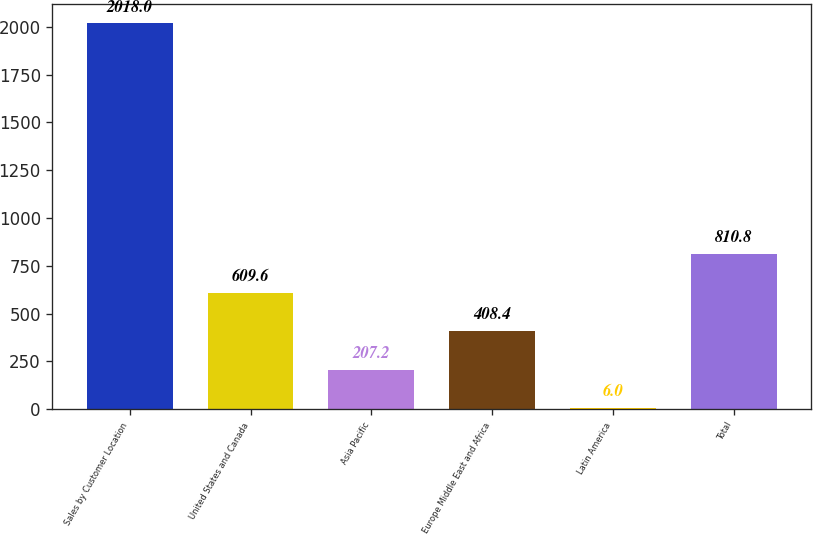<chart> <loc_0><loc_0><loc_500><loc_500><bar_chart><fcel>Sales by Customer Location<fcel>United States and Canada<fcel>Asia Pacific<fcel>Europe Middle East and Africa<fcel>Latin America<fcel>Total<nl><fcel>2018<fcel>609.6<fcel>207.2<fcel>408.4<fcel>6<fcel>810.8<nl></chart> 